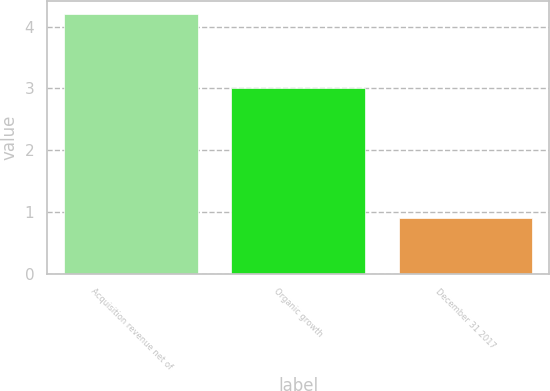<chart> <loc_0><loc_0><loc_500><loc_500><bar_chart><fcel>Acquisition revenue net of<fcel>Organic growth<fcel>December 31 2017<nl><fcel>4.2<fcel>3<fcel>0.9<nl></chart> 